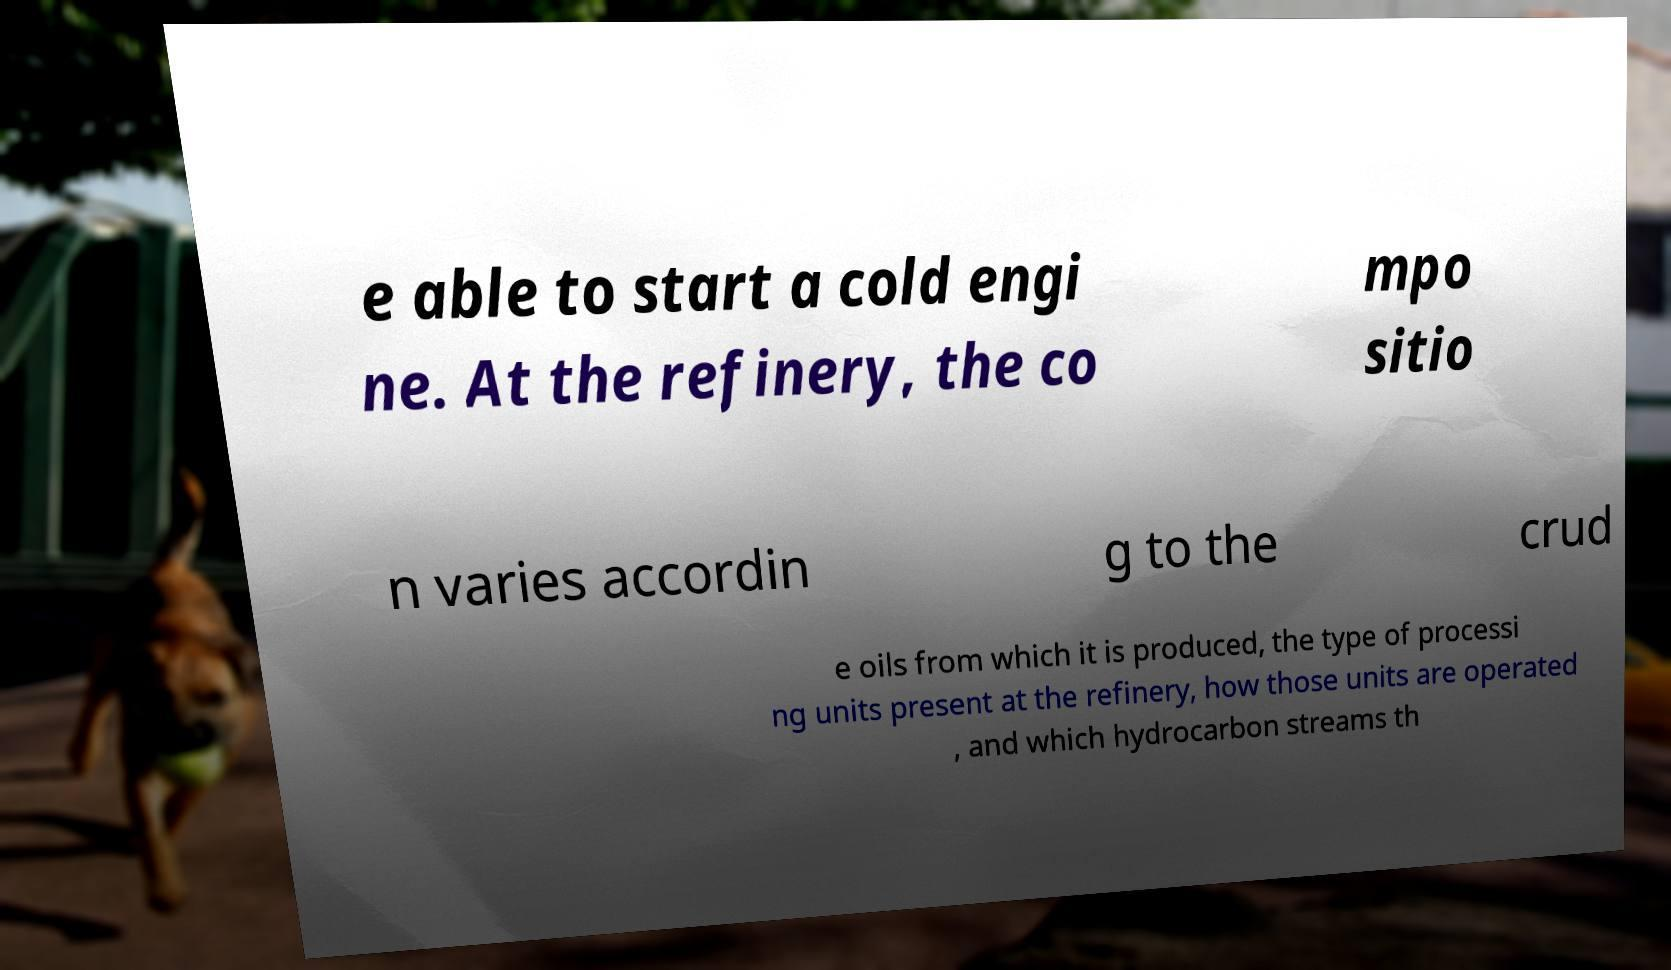There's text embedded in this image that I need extracted. Can you transcribe it verbatim? e able to start a cold engi ne. At the refinery, the co mpo sitio n varies accordin g to the crud e oils from which it is produced, the type of processi ng units present at the refinery, how those units are operated , and which hydrocarbon streams th 